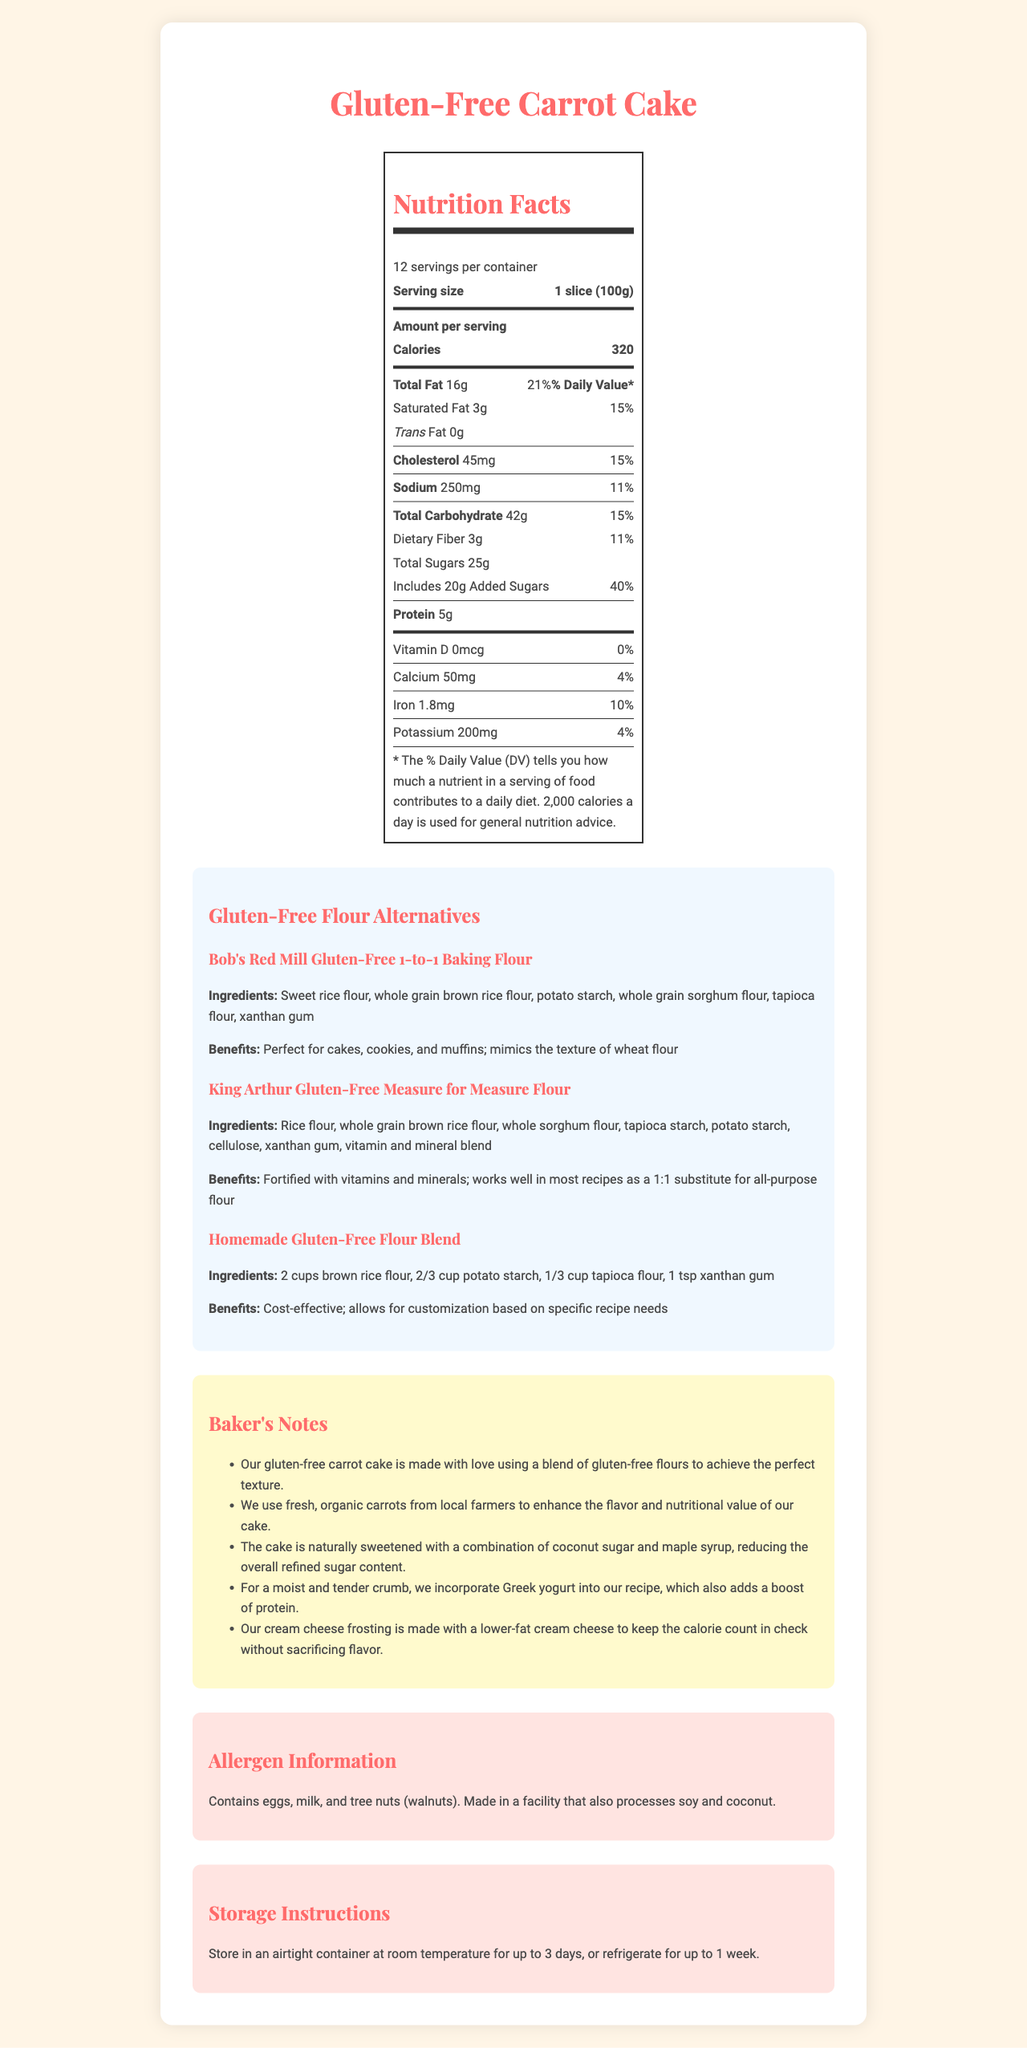what is the serving size of the Gluten-Free Carrot Cake? The serving size is explicitly mentioned in the nutrition facts section of the document.
Answer: 1 slice (100g) how many servings are in one container? The total number of servings per container is provided at the beginning of the nutrition facts section.
Answer: 12 servings per container how many calories are there per serving? The calories per serving are listed prominently under the "Amount per serving" section.
Answer: 320 calories what is the percentage of daily value for total fat? The percentage of daily value for total fat is located next to the total fat amount in the nutrition facts section.
Answer: 21% what is the amount of protein per serving? The protein content per serving is listed under the nutrients information in the nutrition facts section.
Answer: 5g which gluten-free flour alternative includes a vitamin and mineral blend? The description for King Arthur Gluten-Free Measure for Measure Flour mentions it is fortified with vitamins and minerals.
Answer: King Arthur Gluten-Free Measure for Measure Flour what should be the storage method for the cake? A. Freeze immediately B. Store at room temperature for up to 3 days C. Refrigerate for up to a week According to the storage instructions, the cake can be stored at room temperature for up to 3 days or refrigerated for up to a week.
Answer: B and C which ingredient is not in Bob's Red Mill Gluten-Free 1-to-1 Baking Flour? A. Sweet rice flour B. Potato starch C. White rice flour White rice flour is not listed as one of the ingredients for Bob's Red Mill Gluten-Free 1-to-1 Baking Flour.
Answer: C does the Gluten-Free Carrot Cake contain any allergens? The document states that the cake contains eggs, milk, and tree nuts (walnuts) and is made in a facility that processes soy and coconut.
Answer: Yes how is the cake naturally sweetened? The baker's notes mention that the cake is sweetened with coconut sugar and maple syrup to reduce refined sugar content.
Answer: With a combination of coconut sugar and maple syrup can this document tell us where to buy the gluten-free flour alternatives? The visual information in the document does not include details about purchasing locations for the gluten-free flour alternatives.
Answer: Cannot be determined summarize the main idea of the document. The document describes the nutritional content, ingredient alternatives, baking notes, allergen information, and storage tips for a Gluten-Free Carrot Cake.
Answer: The document provides detailed nutrition facts, highlights gluten-free flour alternatives, includes baker's notes, allergen information, and storage instructions for a Gluten-Free Carrot Cake. 